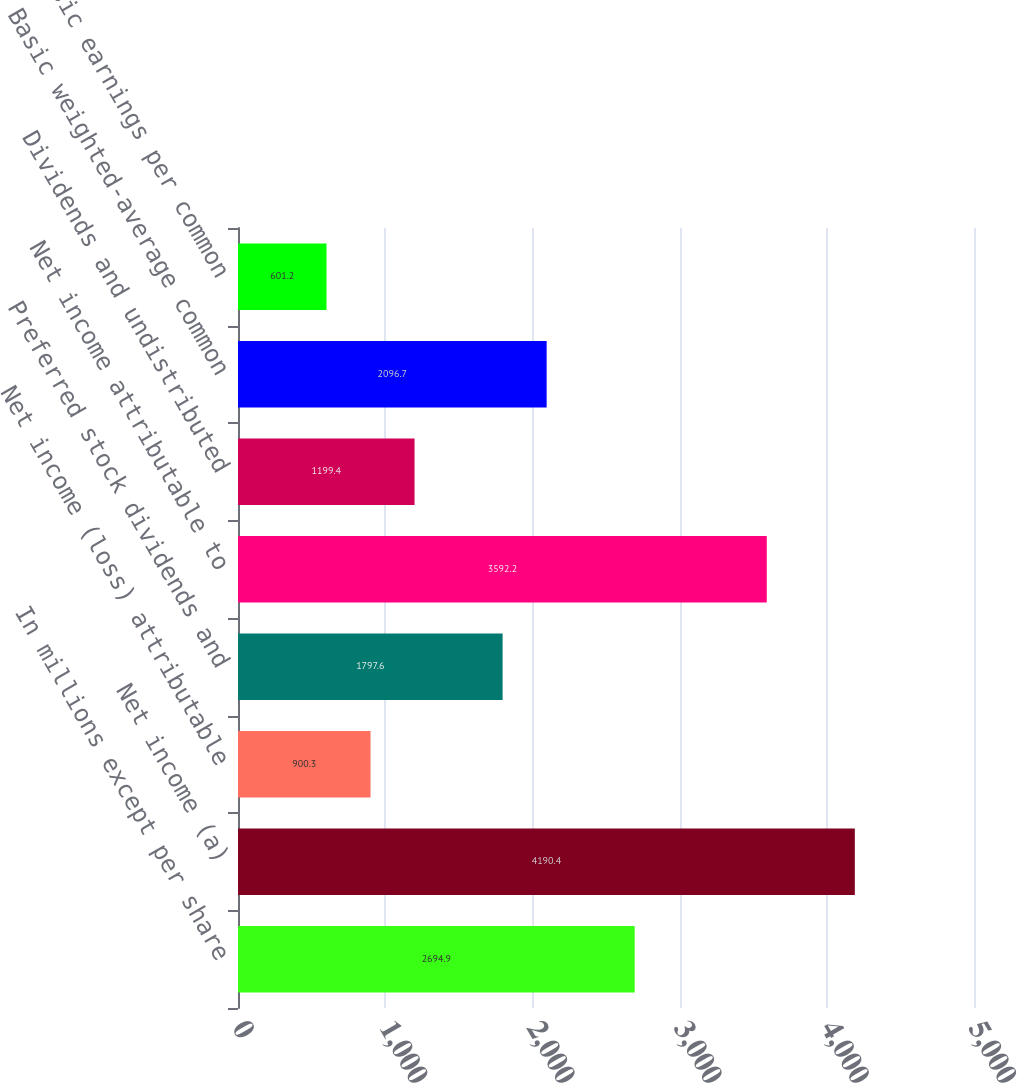<chart> <loc_0><loc_0><loc_500><loc_500><bar_chart><fcel>In millions except per share<fcel>Net income (a)<fcel>Net income (loss) attributable<fcel>Preferred stock dividends and<fcel>Net income attributable to<fcel>Dividends and undistributed<fcel>Basic weighted-average common<fcel>Basic earnings per common<nl><fcel>2694.9<fcel>4190.4<fcel>900.3<fcel>1797.6<fcel>3592.2<fcel>1199.4<fcel>2096.7<fcel>601.2<nl></chart> 